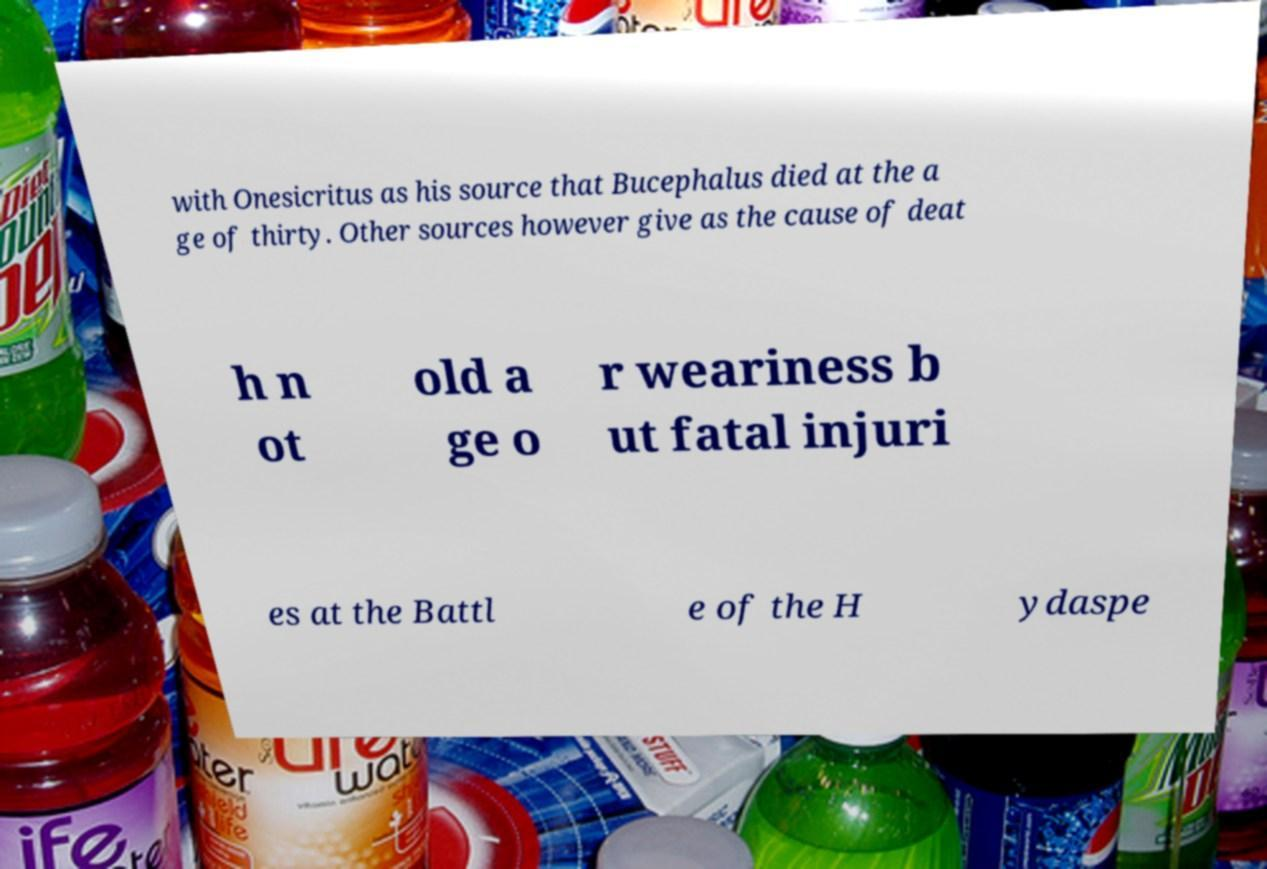Could you assist in decoding the text presented in this image and type it out clearly? with Onesicritus as his source that Bucephalus died at the a ge of thirty. Other sources however give as the cause of deat h n ot old a ge o r weariness b ut fatal injuri es at the Battl e of the H ydaspe 